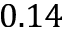Convert formula to latex. <formula><loc_0><loc_0><loc_500><loc_500>0 . 1 4</formula> 